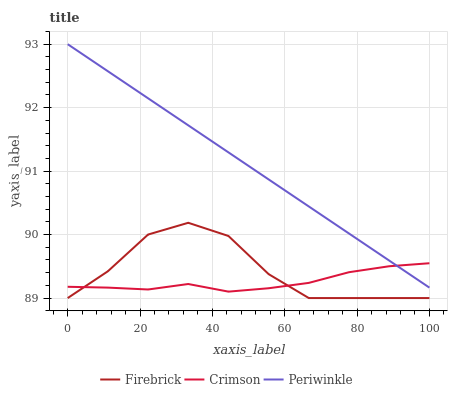Does Crimson have the minimum area under the curve?
Answer yes or no. Yes. Does Periwinkle have the maximum area under the curve?
Answer yes or no. Yes. Does Firebrick have the minimum area under the curve?
Answer yes or no. No. Does Firebrick have the maximum area under the curve?
Answer yes or no. No. Is Periwinkle the smoothest?
Answer yes or no. Yes. Is Firebrick the roughest?
Answer yes or no. Yes. Is Firebrick the smoothest?
Answer yes or no. No. Is Periwinkle the roughest?
Answer yes or no. No. Does Firebrick have the lowest value?
Answer yes or no. Yes. Does Periwinkle have the lowest value?
Answer yes or no. No. Does Periwinkle have the highest value?
Answer yes or no. Yes. Does Firebrick have the highest value?
Answer yes or no. No. Is Firebrick less than Periwinkle?
Answer yes or no. Yes. Is Periwinkle greater than Firebrick?
Answer yes or no. Yes. Does Periwinkle intersect Crimson?
Answer yes or no. Yes. Is Periwinkle less than Crimson?
Answer yes or no. No. Is Periwinkle greater than Crimson?
Answer yes or no. No. Does Firebrick intersect Periwinkle?
Answer yes or no. No. 